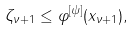<formula> <loc_0><loc_0><loc_500><loc_500>\zeta _ { \nu + 1 } \leq \varphi ^ { [ \psi ] } ( x _ { \nu + 1 } ) ,</formula> 